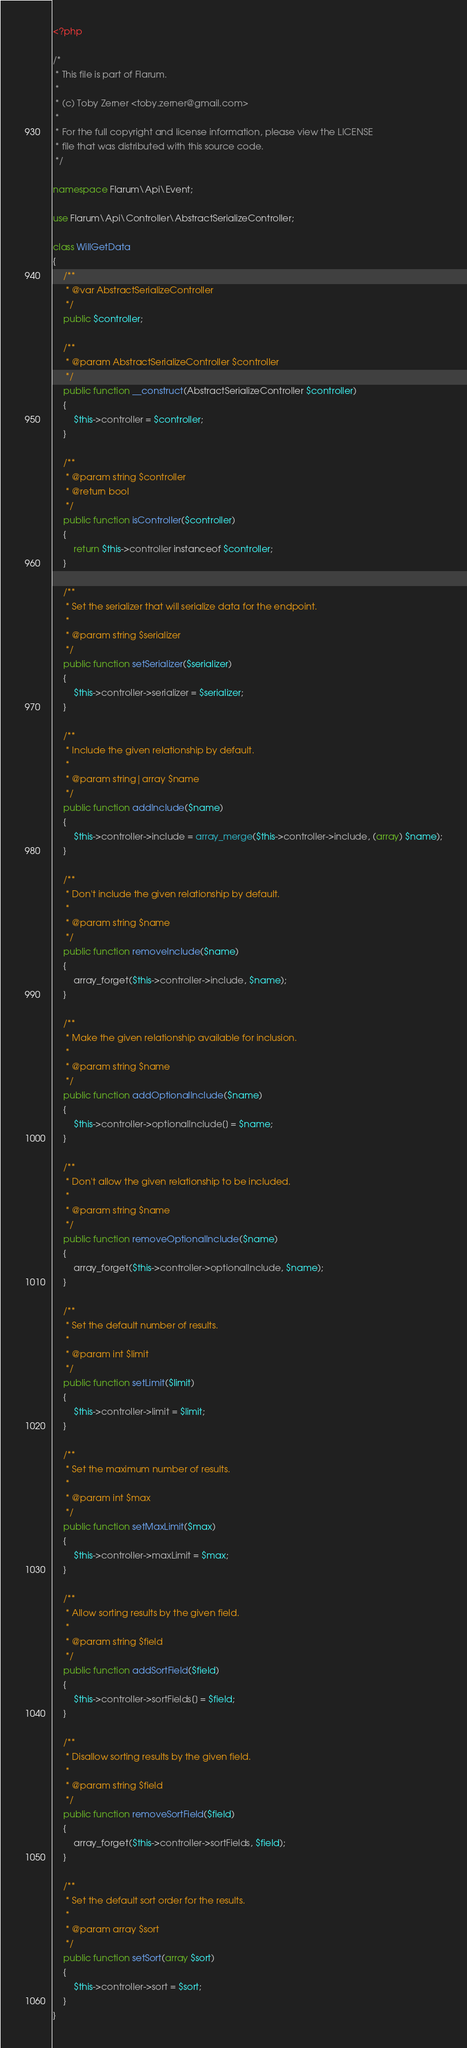<code> <loc_0><loc_0><loc_500><loc_500><_PHP_><?php

/*
 * This file is part of Flarum.
 *
 * (c) Toby Zerner <toby.zerner@gmail.com>
 *
 * For the full copyright and license information, please view the LICENSE
 * file that was distributed with this source code.
 */

namespace Flarum\Api\Event;

use Flarum\Api\Controller\AbstractSerializeController;

class WillGetData
{
    /**
     * @var AbstractSerializeController
     */
    public $controller;

    /**
     * @param AbstractSerializeController $controller
     */
    public function __construct(AbstractSerializeController $controller)
    {
        $this->controller = $controller;
    }

    /**
     * @param string $controller
     * @return bool
     */
    public function isController($controller)
    {
        return $this->controller instanceof $controller;
    }

    /**
     * Set the serializer that will serialize data for the endpoint.
     *
     * @param string $serializer
     */
    public function setSerializer($serializer)
    {
        $this->controller->serializer = $serializer;
    }

    /**
     * Include the given relationship by default.
     *
     * @param string|array $name
     */
    public function addInclude($name)
    {
        $this->controller->include = array_merge($this->controller->include, (array) $name);
    }

    /**
     * Don't include the given relationship by default.
     *
     * @param string $name
     */
    public function removeInclude($name)
    {
        array_forget($this->controller->include, $name);
    }

    /**
     * Make the given relationship available for inclusion.
     *
     * @param string $name
     */
    public function addOptionalInclude($name)
    {
        $this->controller->optionalInclude[] = $name;
    }

    /**
     * Don't allow the given relationship to be included.
     *
     * @param string $name
     */
    public function removeOptionalInclude($name)
    {
        array_forget($this->controller->optionalInclude, $name);
    }

    /**
     * Set the default number of results.
     *
     * @param int $limit
     */
    public function setLimit($limit)
    {
        $this->controller->limit = $limit;
    }

    /**
     * Set the maximum number of results.
     *
     * @param int $max
     */
    public function setMaxLimit($max)
    {
        $this->controller->maxLimit = $max;
    }

    /**
     * Allow sorting results by the given field.
     *
     * @param string $field
     */
    public function addSortField($field)
    {
        $this->controller->sortFields[] = $field;
    }

    /**
     * Disallow sorting results by the given field.
     *
     * @param string $field
     */
    public function removeSortField($field)
    {
        array_forget($this->controller->sortFields, $field);
    }

    /**
     * Set the default sort order for the results.
     *
     * @param array $sort
     */
    public function setSort(array $sort)
    {
        $this->controller->sort = $sort;
    }
}
</code> 